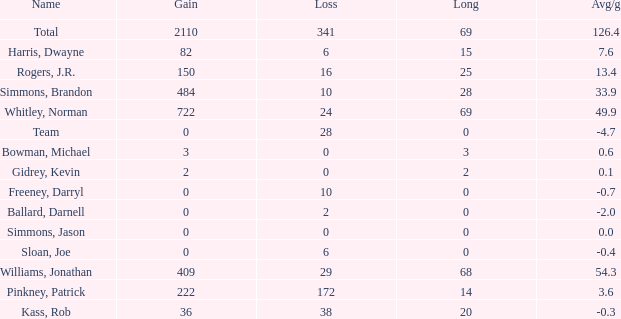What is the average Loss, when Avg/g is 0, and when Long is less than 0? None. 